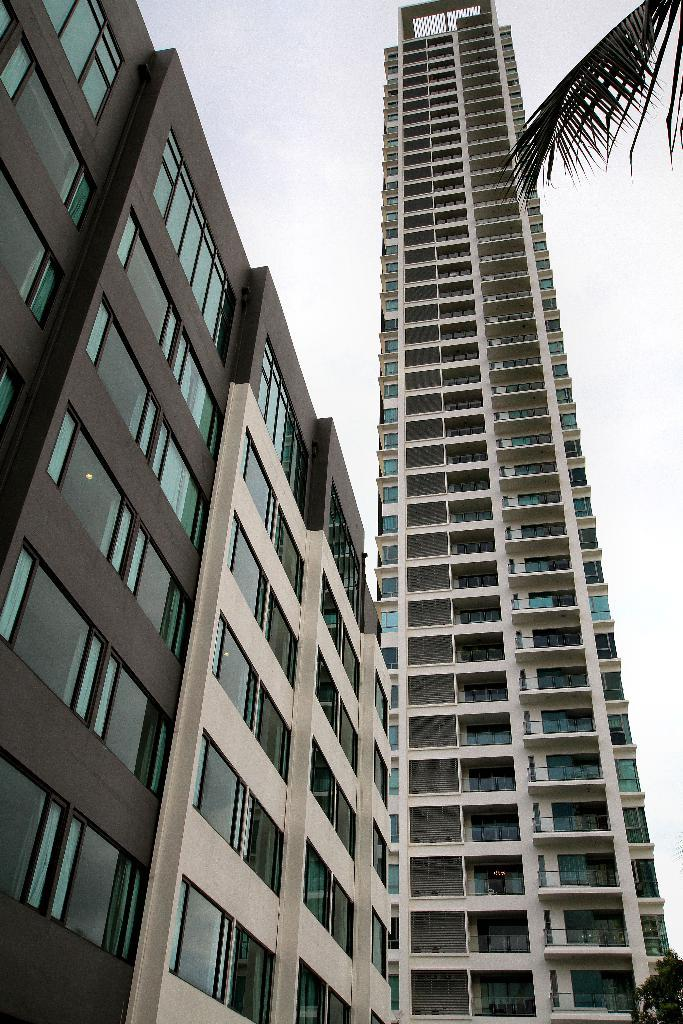What type of structure is present in the image? There is a building and a skyscraper in the image. Can you describe the vegetation in the image? There is a coconut tree in the top right corner of the image. What is visible at the top of the image? The sky is visible at the top of the image. What type of government is depicted in the image? There is no depiction of a government in the image; it features a building, a skyscraper, a coconut tree, and the sky. What belief system is represented in the image? There is no representation of a belief system in the image; it is a visual representation of a building, a skyscraper, a coconut tree, and the sky. 